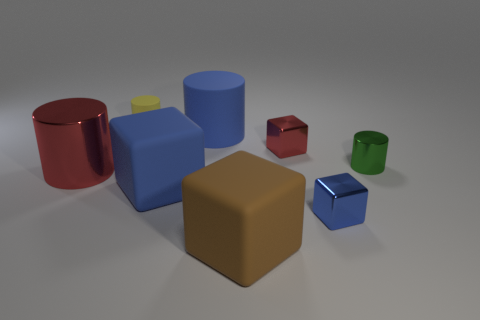Are there any shiny cubes that are in front of the thing that is to the left of the tiny yellow cylinder?
Your answer should be compact. Yes. Is the size of the cube that is behind the blue rubber block the same as the tiny blue metallic block?
Your answer should be very brief. Yes. The red block is what size?
Ensure brevity in your answer.  Small. Are there any tiny matte balls of the same color as the large metal object?
Your answer should be compact. No. What number of large things are blue objects or yellow cylinders?
Keep it short and to the point. 2. There is a cylinder that is in front of the tiny red metal block and on the left side of the big brown thing; what size is it?
Offer a terse response. Large. What number of tiny blocks are right of the green thing?
Offer a very short reply. 0. The rubber object that is both left of the blue rubber cylinder and in front of the red shiny cylinder has what shape?
Ensure brevity in your answer.  Cube. What material is the cube that is the same color as the large metallic object?
Your answer should be very brief. Metal. How many blocks are either red things or yellow objects?
Your answer should be very brief. 1. 